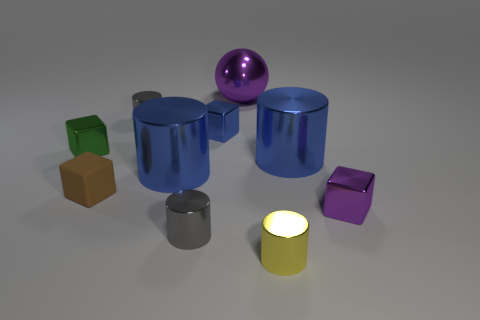Subtract 1 cylinders. How many cylinders are left? 4 Subtract all yellow cylinders. How many cylinders are left? 4 Subtract all small yellow shiny cylinders. How many cylinders are left? 4 Subtract all gray cubes. Subtract all red spheres. How many cubes are left? 4 Subtract all spheres. How many objects are left? 9 Subtract all small green cylinders. Subtract all large objects. How many objects are left? 7 Add 2 metal spheres. How many metal spheres are left? 3 Add 6 big yellow shiny cylinders. How many big yellow shiny cylinders exist? 6 Subtract 0 green cylinders. How many objects are left? 10 